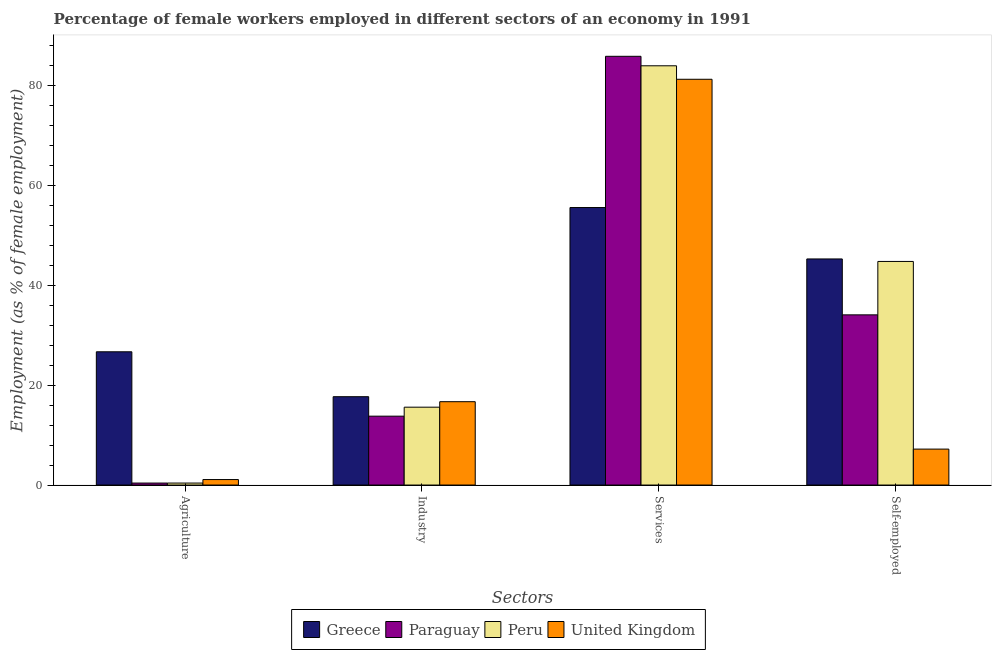How many different coloured bars are there?
Ensure brevity in your answer.  4. How many groups of bars are there?
Ensure brevity in your answer.  4. Are the number of bars per tick equal to the number of legend labels?
Offer a very short reply. Yes. Are the number of bars on each tick of the X-axis equal?
Your answer should be compact. Yes. How many bars are there on the 1st tick from the right?
Keep it short and to the point. 4. What is the label of the 2nd group of bars from the left?
Your answer should be very brief. Industry. What is the percentage of female workers in agriculture in Paraguay?
Your answer should be very brief. 0.4. Across all countries, what is the maximum percentage of female workers in services?
Offer a very short reply. 85.9. Across all countries, what is the minimum percentage of self employed female workers?
Give a very brief answer. 7.2. In which country was the percentage of self employed female workers maximum?
Offer a very short reply. Greece. In which country was the percentage of self employed female workers minimum?
Ensure brevity in your answer.  United Kingdom. What is the total percentage of female workers in industry in the graph?
Make the answer very short. 63.8. What is the difference between the percentage of self employed female workers in Peru and that in Greece?
Make the answer very short. -0.5. What is the difference between the percentage of female workers in agriculture in Peru and the percentage of female workers in industry in Greece?
Ensure brevity in your answer.  -17.3. What is the average percentage of female workers in services per country?
Ensure brevity in your answer.  76.7. What is the difference between the percentage of female workers in agriculture and percentage of female workers in services in Paraguay?
Offer a terse response. -85.5. What is the ratio of the percentage of female workers in services in United Kingdom to that in Paraguay?
Keep it short and to the point. 0.95. Is the difference between the percentage of self employed female workers in Peru and Greece greater than the difference between the percentage of female workers in services in Peru and Greece?
Offer a very short reply. No. What is the difference between the highest and the second highest percentage of female workers in agriculture?
Give a very brief answer. 25.6. What is the difference between the highest and the lowest percentage of female workers in agriculture?
Provide a short and direct response. 26.3. In how many countries, is the percentage of female workers in agriculture greater than the average percentage of female workers in agriculture taken over all countries?
Your response must be concise. 1. What does the 2nd bar from the right in Agriculture represents?
Keep it short and to the point. Peru. What is the difference between two consecutive major ticks on the Y-axis?
Your answer should be compact. 20. Does the graph contain grids?
Provide a short and direct response. No. How are the legend labels stacked?
Your response must be concise. Horizontal. What is the title of the graph?
Make the answer very short. Percentage of female workers employed in different sectors of an economy in 1991. What is the label or title of the X-axis?
Ensure brevity in your answer.  Sectors. What is the label or title of the Y-axis?
Your answer should be very brief. Employment (as % of female employment). What is the Employment (as % of female employment) of Greece in Agriculture?
Offer a terse response. 26.7. What is the Employment (as % of female employment) of Paraguay in Agriculture?
Give a very brief answer. 0.4. What is the Employment (as % of female employment) of Peru in Agriculture?
Give a very brief answer. 0.4. What is the Employment (as % of female employment) in United Kingdom in Agriculture?
Your answer should be compact. 1.1. What is the Employment (as % of female employment) in Greece in Industry?
Make the answer very short. 17.7. What is the Employment (as % of female employment) in Paraguay in Industry?
Your answer should be compact. 13.8. What is the Employment (as % of female employment) in Peru in Industry?
Make the answer very short. 15.6. What is the Employment (as % of female employment) of United Kingdom in Industry?
Provide a succinct answer. 16.7. What is the Employment (as % of female employment) of Greece in Services?
Your answer should be very brief. 55.6. What is the Employment (as % of female employment) in Paraguay in Services?
Ensure brevity in your answer.  85.9. What is the Employment (as % of female employment) of United Kingdom in Services?
Give a very brief answer. 81.3. What is the Employment (as % of female employment) of Greece in Self-employed?
Provide a short and direct response. 45.3. What is the Employment (as % of female employment) of Paraguay in Self-employed?
Keep it short and to the point. 34.1. What is the Employment (as % of female employment) in Peru in Self-employed?
Your response must be concise. 44.8. What is the Employment (as % of female employment) of United Kingdom in Self-employed?
Provide a succinct answer. 7.2. Across all Sectors, what is the maximum Employment (as % of female employment) in Greece?
Your response must be concise. 55.6. Across all Sectors, what is the maximum Employment (as % of female employment) of Paraguay?
Provide a succinct answer. 85.9. Across all Sectors, what is the maximum Employment (as % of female employment) in United Kingdom?
Give a very brief answer. 81.3. Across all Sectors, what is the minimum Employment (as % of female employment) in Greece?
Keep it short and to the point. 17.7. Across all Sectors, what is the minimum Employment (as % of female employment) of Paraguay?
Provide a short and direct response. 0.4. Across all Sectors, what is the minimum Employment (as % of female employment) in Peru?
Your answer should be compact. 0.4. Across all Sectors, what is the minimum Employment (as % of female employment) of United Kingdom?
Offer a terse response. 1.1. What is the total Employment (as % of female employment) of Greece in the graph?
Give a very brief answer. 145.3. What is the total Employment (as % of female employment) in Paraguay in the graph?
Your answer should be very brief. 134.2. What is the total Employment (as % of female employment) of Peru in the graph?
Offer a very short reply. 144.8. What is the total Employment (as % of female employment) in United Kingdom in the graph?
Make the answer very short. 106.3. What is the difference between the Employment (as % of female employment) in Paraguay in Agriculture and that in Industry?
Your answer should be very brief. -13.4. What is the difference between the Employment (as % of female employment) in Peru in Agriculture and that in Industry?
Offer a terse response. -15.2. What is the difference between the Employment (as % of female employment) of United Kingdom in Agriculture and that in Industry?
Your answer should be compact. -15.6. What is the difference between the Employment (as % of female employment) of Greece in Agriculture and that in Services?
Your answer should be very brief. -28.9. What is the difference between the Employment (as % of female employment) in Paraguay in Agriculture and that in Services?
Your answer should be very brief. -85.5. What is the difference between the Employment (as % of female employment) in Peru in Agriculture and that in Services?
Give a very brief answer. -83.6. What is the difference between the Employment (as % of female employment) in United Kingdom in Agriculture and that in Services?
Give a very brief answer. -80.2. What is the difference between the Employment (as % of female employment) of Greece in Agriculture and that in Self-employed?
Offer a terse response. -18.6. What is the difference between the Employment (as % of female employment) in Paraguay in Agriculture and that in Self-employed?
Make the answer very short. -33.7. What is the difference between the Employment (as % of female employment) of Peru in Agriculture and that in Self-employed?
Provide a succinct answer. -44.4. What is the difference between the Employment (as % of female employment) in United Kingdom in Agriculture and that in Self-employed?
Make the answer very short. -6.1. What is the difference between the Employment (as % of female employment) of Greece in Industry and that in Services?
Offer a terse response. -37.9. What is the difference between the Employment (as % of female employment) in Paraguay in Industry and that in Services?
Provide a succinct answer. -72.1. What is the difference between the Employment (as % of female employment) in Peru in Industry and that in Services?
Provide a short and direct response. -68.4. What is the difference between the Employment (as % of female employment) in United Kingdom in Industry and that in Services?
Your response must be concise. -64.6. What is the difference between the Employment (as % of female employment) in Greece in Industry and that in Self-employed?
Give a very brief answer. -27.6. What is the difference between the Employment (as % of female employment) in Paraguay in Industry and that in Self-employed?
Offer a very short reply. -20.3. What is the difference between the Employment (as % of female employment) of Peru in Industry and that in Self-employed?
Give a very brief answer. -29.2. What is the difference between the Employment (as % of female employment) of Paraguay in Services and that in Self-employed?
Keep it short and to the point. 51.8. What is the difference between the Employment (as % of female employment) in Peru in Services and that in Self-employed?
Offer a very short reply. 39.2. What is the difference between the Employment (as % of female employment) in United Kingdom in Services and that in Self-employed?
Keep it short and to the point. 74.1. What is the difference between the Employment (as % of female employment) in Greece in Agriculture and the Employment (as % of female employment) in Paraguay in Industry?
Make the answer very short. 12.9. What is the difference between the Employment (as % of female employment) of Greece in Agriculture and the Employment (as % of female employment) of Peru in Industry?
Give a very brief answer. 11.1. What is the difference between the Employment (as % of female employment) of Greece in Agriculture and the Employment (as % of female employment) of United Kingdom in Industry?
Your answer should be very brief. 10. What is the difference between the Employment (as % of female employment) in Paraguay in Agriculture and the Employment (as % of female employment) in Peru in Industry?
Give a very brief answer. -15.2. What is the difference between the Employment (as % of female employment) of Paraguay in Agriculture and the Employment (as % of female employment) of United Kingdom in Industry?
Your answer should be very brief. -16.3. What is the difference between the Employment (as % of female employment) of Peru in Agriculture and the Employment (as % of female employment) of United Kingdom in Industry?
Give a very brief answer. -16.3. What is the difference between the Employment (as % of female employment) in Greece in Agriculture and the Employment (as % of female employment) in Paraguay in Services?
Give a very brief answer. -59.2. What is the difference between the Employment (as % of female employment) of Greece in Agriculture and the Employment (as % of female employment) of Peru in Services?
Your response must be concise. -57.3. What is the difference between the Employment (as % of female employment) in Greece in Agriculture and the Employment (as % of female employment) in United Kingdom in Services?
Ensure brevity in your answer.  -54.6. What is the difference between the Employment (as % of female employment) of Paraguay in Agriculture and the Employment (as % of female employment) of Peru in Services?
Give a very brief answer. -83.6. What is the difference between the Employment (as % of female employment) in Paraguay in Agriculture and the Employment (as % of female employment) in United Kingdom in Services?
Provide a short and direct response. -80.9. What is the difference between the Employment (as % of female employment) of Peru in Agriculture and the Employment (as % of female employment) of United Kingdom in Services?
Your answer should be compact. -80.9. What is the difference between the Employment (as % of female employment) in Greece in Agriculture and the Employment (as % of female employment) in Paraguay in Self-employed?
Offer a terse response. -7.4. What is the difference between the Employment (as % of female employment) of Greece in Agriculture and the Employment (as % of female employment) of Peru in Self-employed?
Provide a succinct answer. -18.1. What is the difference between the Employment (as % of female employment) of Greece in Agriculture and the Employment (as % of female employment) of United Kingdom in Self-employed?
Offer a terse response. 19.5. What is the difference between the Employment (as % of female employment) in Paraguay in Agriculture and the Employment (as % of female employment) in Peru in Self-employed?
Your answer should be compact. -44.4. What is the difference between the Employment (as % of female employment) in Paraguay in Agriculture and the Employment (as % of female employment) in United Kingdom in Self-employed?
Keep it short and to the point. -6.8. What is the difference between the Employment (as % of female employment) in Greece in Industry and the Employment (as % of female employment) in Paraguay in Services?
Make the answer very short. -68.2. What is the difference between the Employment (as % of female employment) of Greece in Industry and the Employment (as % of female employment) of Peru in Services?
Your answer should be very brief. -66.3. What is the difference between the Employment (as % of female employment) in Greece in Industry and the Employment (as % of female employment) in United Kingdom in Services?
Ensure brevity in your answer.  -63.6. What is the difference between the Employment (as % of female employment) of Paraguay in Industry and the Employment (as % of female employment) of Peru in Services?
Give a very brief answer. -70.2. What is the difference between the Employment (as % of female employment) of Paraguay in Industry and the Employment (as % of female employment) of United Kingdom in Services?
Give a very brief answer. -67.5. What is the difference between the Employment (as % of female employment) of Peru in Industry and the Employment (as % of female employment) of United Kingdom in Services?
Provide a succinct answer. -65.7. What is the difference between the Employment (as % of female employment) of Greece in Industry and the Employment (as % of female employment) of Paraguay in Self-employed?
Offer a terse response. -16.4. What is the difference between the Employment (as % of female employment) in Greece in Industry and the Employment (as % of female employment) in Peru in Self-employed?
Give a very brief answer. -27.1. What is the difference between the Employment (as % of female employment) of Paraguay in Industry and the Employment (as % of female employment) of Peru in Self-employed?
Provide a short and direct response. -31. What is the difference between the Employment (as % of female employment) of Paraguay in Industry and the Employment (as % of female employment) of United Kingdom in Self-employed?
Your answer should be very brief. 6.6. What is the difference between the Employment (as % of female employment) of Peru in Industry and the Employment (as % of female employment) of United Kingdom in Self-employed?
Keep it short and to the point. 8.4. What is the difference between the Employment (as % of female employment) of Greece in Services and the Employment (as % of female employment) of United Kingdom in Self-employed?
Keep it short and to the point. 48.4. What is the difference between the Employment (as % of female employment) of Paraguay in Services and the Employment (as % of female employment) of Peru in Self-employed?
Keep it short and to the point. 41.1. What is the difference between the Employment (as % of female employment) in Paraguay in Services and the Employment (as % of female employment) in United Kingdom in Self-employed?
Offer a very short reply. 78.7. What is the difference between the Employment (as % of female employment) in Peru in Services and the Employment (as % of female employment) in United Kingdom in Self-employed?
Keep it short and to the point. 76.8. What is the average Employment (as % of female employment) of Greece per Sectors?
Provide a succinct answer. 36.33. What is the average Employment (as % of female employment) in Paraguay per Sectors?
Provide a succinct answer. 33.55. What is the average Employment (as % of female employment) of Peru per Sectors?
Give a very brief answer. 36.2. What is the average Employment (as % of female employment) of United Kingdom per Sectors?
Your response must be concise. 26.57. What is the difference between the Employment (as % of female employment) of Greece and Employment (as % of female employment) of Paraguay in Agriculture?
Ensure brevity in your answer.  26.3. What is the difference between the Employment (as % of female employment) in Greece and Employment (as % of female employment) in Peru in Agriculture?
Your answer should be very brief. 26.3. What is the difference between the Employment (as % of female employment) of Greece and Employment (as % of female employment) of United Kingdom in Agriculture?
Offer a very short reply. 25.6. What is the difference between the Employment (as % of female employment) in Paraguay and Employment (as % of female employment) in Peru in Agriculture?
Keep it short and to the point. 0. What is the difference between the Employment (as % of female employment) of Paraguay and Employment (as % of female employment) of United Kingdom in Agriculture?
Offer a terse response. -0.7. What is the difference between the Employment (as % of female employment) of Peru and Employment (as % of female employment) of United Kingdom in Agriculture?
Your response must be concise. -0.7. What is the difference between the Employment (as % of female employment) in Greece and Employment (as % of female employment) in Peru in Industry?
Your answer should be compact. 2.1. What is the difference between the Employment (as % of female employment) in Paraguay and Employment (as % of female employment) in United Kingdom in Industry?
Give a very brief answer. -2.9. What is the difference between the Employment (as % of female employment) of Peru and Employment (as % of female employment) of United Kingdom in Industry?
Your response must be concise. -1.1. What is the difference between the Employment (as % of female employment) in Greece and Employment (as % of female employment) in Paraguay in Services?
Your answer should be very brief. -30.3. What is the difference between the Employment (as % of female employment) in Greece and Employment (as % of female employment) in Peru in Services?
Make the answer very short. -28.4. What is the difference between the Employment (as % of female employment) in Greece and Employment (as % of female employment) in United Kingdom in Services?
Provide a succinct answer. -25.7. What is the difference between the Employment (as % of female employment) in Greece and Employment (as % of female employment) in Paraguay in Self-employed?
Your answer should be very brief. 11.2. What is the difference between the Employment (as % of female employment) in Greece and Employment (as % of female employment) in Peru in Self-employed?
Your answer should be very brief. 0.5. What is the difference between the Employment (as % of female employment) in Greece and Employment (as % of female employment) in United Kingdom in Self-employed?
Provide a succinct answer. 38.1. What is the difference between the Employment (as % of female employment) in Paraguay and Employment (as % of female employment) in Peru in Self-employed?
Offer a very short reply. -10.7. What is the difference between the Employment (as % of female employment) in Paraguay and Employment (as % of female employment) in United Kingdom in Self-employed?
Provide a short and direct response. 26.9. What is the difference between the Employment (as % of female employment) of Peru and Employment (as % of female employment) of United Kingdom in Self-employed?
Your response must be concise. 37.6. What is the ratio of the Employment (as % of female employment) of Greece in Agriculture to that in Industry?
Make the answer very short. 1.51. What is the ratio of the Employment (as % of female employment) in Paraguay in Agriculture to that in Industry?
Provide a short and direct response. 0.03. What is the ratio of the Employment (as % of female employment) of Peru in Agriculture to that in Industry?
Provide a short and direct response. 0.03. What is the ratio of the Employment (as % of female employment) in United Kingdom in Agriculture to that in Industry?
Provide a short and direct response. 0.07. What is the ratio of the Employment (as % of female employment) in Greece in Agriculture to that in Services?
Provide a succinct answer. 0.48. What is the ratio of the Employment (as % of female employment) of Paraguay in Agriculture to that in Services?
Offer a terse response. 0. What is the ratio of the Employment (as % of female employment) in Peru in Agriculture to that in Services?
Your answer should be compact. 0. What is the ratio of the Employment (as % of female employment) of United Kingdom in Agriculture to that in Services?
Keep it short and to the point. 0.01. What is the ratio of the Employment (as % of female employment) of Greece in Agriculture to that in Self-employed?
Keep it short and to the point. 0.59. What is the ratio of the Employment (as % of female employment) of Paraguay in Agriculture to that in Self-employed?
Your answer should be compact. 0.01. What is the ratio of the Employment (as % of female employment) in Peru in Agriculture to that in Self-employed?
Provide a short and direct response. 0.01. What is the ratio of the Employment (as % of female employment) of United Kingdom in Agriculture to that in Self-employed?
Your answer should be compact. 0.15. What is the ratio of the Employment (as % of female employment) of Greece in Industry to that in Services?
Your answer should be compact. 0.32. What is the ratio of the Employment (as % of female employment) in Paraguay in Industry to that in Services?
Keep it short and to the point. 0.16. What is the ratio of the Employment (as % of female employment) in Peru in Industry to that in Services?
Offer a terse response. 0.19. What is the ratio of the Employment (as % of female employment) in United Kingdom in Industry to that in Services?
Give a very brief answer. 0.21. What is the ratio of the Employment (as % of female employment) of Greece in Industry to that in Self-employed?
Your response must be concise. 0.39. What is the ratio of the Employment (as % of female employment) in Paraguay in Industry to that in Self-employed?
Provide a succinct answer. 0.4. What is the ratio of the Employment (as % of female employment) of Peru in Industry to that in Self-employed?
Your response must be concise. 0.35. What is the ratio of the Employment (as % of female employment) in United Kingdom in Industry to that in Self-employed?
Provide a short and direct response. 2.32. What is the ratio of the Employment (as % of female employment) of Greece in Services to that in Self-employed?
Offer a terse response. 1.23. What is the ratio of the Employment (as % of female employment) in Paraguay in Services to that in Self-employed?
Your answer should be very brief. 2.52. What is the ratio of the Employment (as % of female employment) of Peru in Services to that in Self-employed?
Your answer should be very brief. 1.88. What is the ratio of the Employment (as % of female employment) in United Kingdom in Services to that in Self-employed?
Make the answer very short. 11.29. What is the difference between the highest and the second highest Employment (as % of female employment) in Greece?
Make the answer very short. 10.3. What is the difference between the highest and the second highest Employment (as % of female employment) in Paraguay?
Make the answer very short. 51.8. What is the difference between the highest and the second highest Employment (as % of female employment) in Peru?
Make the answer very short. 39.2. What is the difference between the highest and the second highest Employment (as % of female employment) of United Kingdom?
Give a very brief answer. 64.6. What is the difference between the highest and the lowest Employment (as % of female employment) in Greece?
Keep it short and to the point. 37.9. What is the difference between the highest and the lowest Employment (as % of female employment) in Paraguay?
Your answer should be compact. 85.5. What is the difference between the highest and the lowest Employment (as % of female employment) in Peru?
Provide a short and direct response. 83.6. What is the difference between the highest and the lowest Employment (as % of female employment) in United Kingdom?
Offer a very short reply. 80.2. 